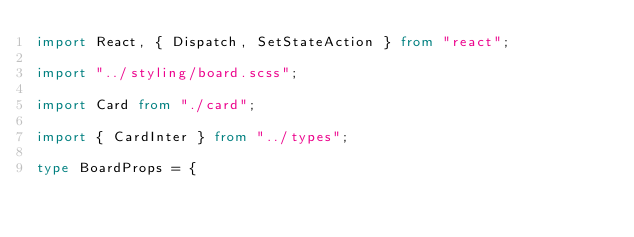<code> <loc_0><loc_0><loc_500><loc_500><_TypeScript_>import React, { Dispatch, SetStateAction } from "react";

import "../styling/board.scss";

import Card from "./card";

import { CardInter } from "../types";

type BoardProps = {</code> 